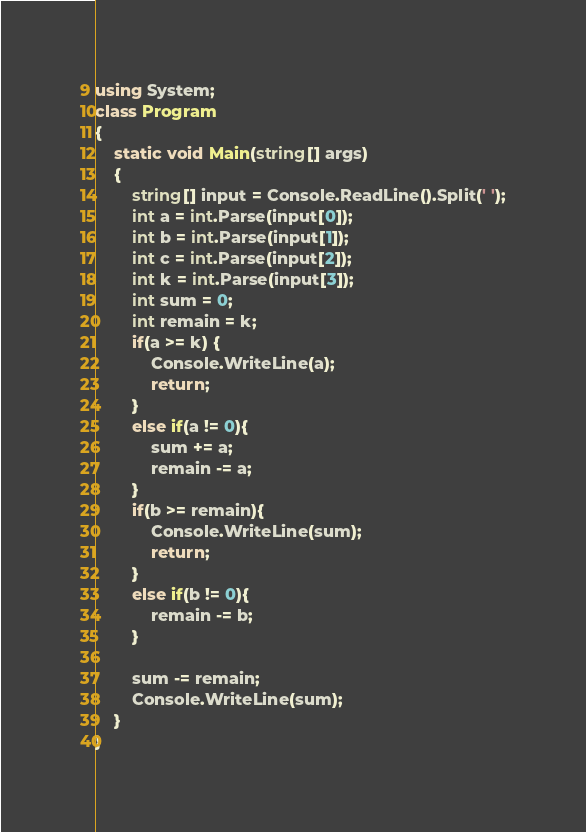Convert code to text. <code><loc_0><loc_0><loc_500><loc_500><_C#_>using System;
class Program
{
	static void Main(string[] args)
	{
		string[] input = Console.ReadLine().Split(' ');
		int a = int.Parse(input[0]);
		int b = int.Parse(input[1]);
        int c = int.Parse(input[2]);
        int k = int.Parse(input[3]);
        int sum = 0;
        int remain = k;
        if(a >= k) {
            Console.WriteLine(a);
            return;
        }
        else if(a != 0){
            sum += a;
            remain -= a;
        }
        if(b >= remain){
            Console.WriteLine(sum);
            return;
        }
        else if(b != 0){    
            remain -= b;
        }
        
        sum -= remain;
        Console.WriteLine(sum);
	}
}</code> 